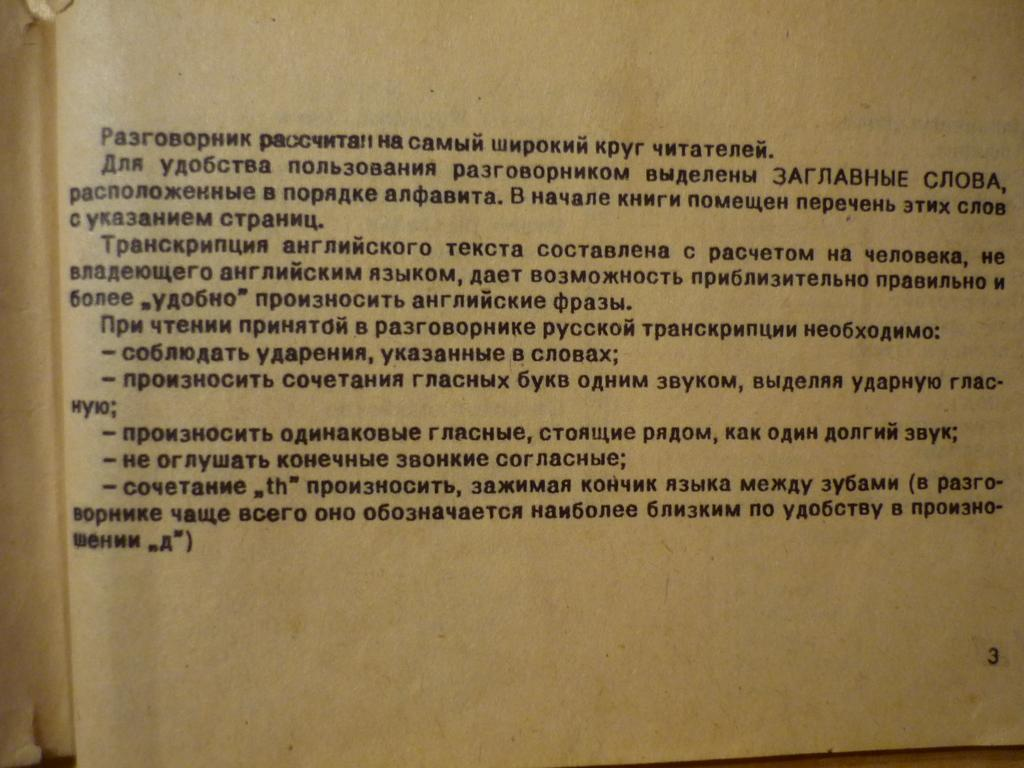<image>
Relay a brief, clear account of the picture shown. A book is open to page number 3. 